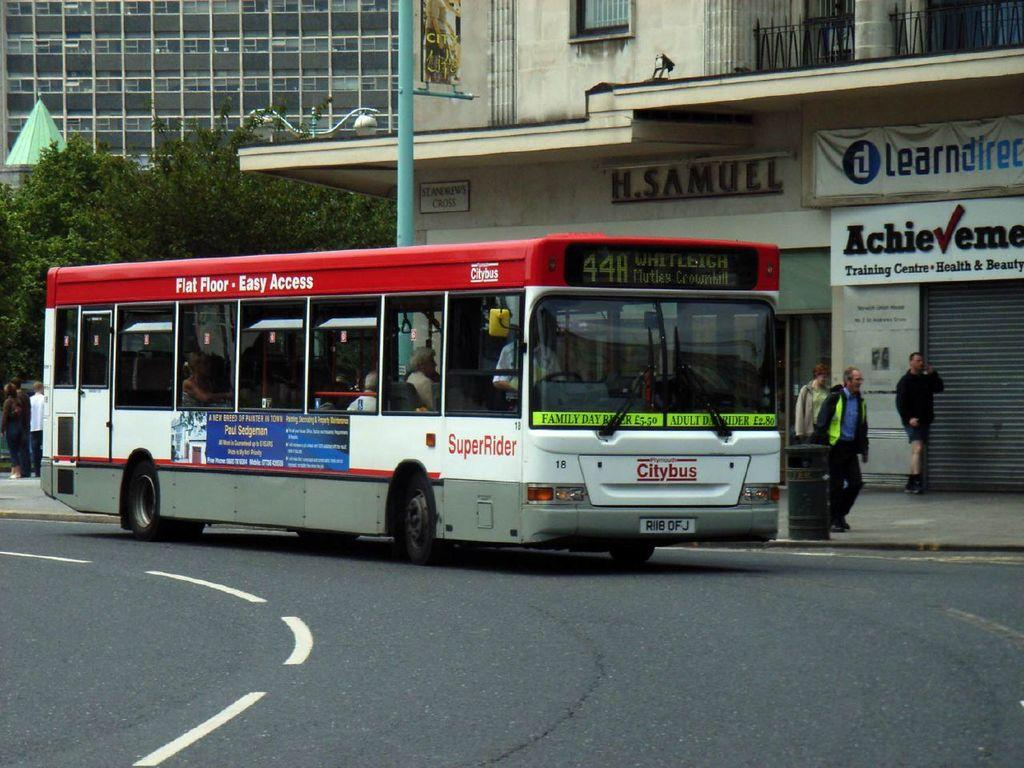What type of vehicle is on the road in the image? There is a bus on the road in the image. What can be seen in the background of the image? In the background of the image, there are people, a bin, buildings, boards, and trees. Are there any artificial light sources visible in the image? Yes, there are lights in the image. What structure can be seen in the image that is used for supporting objects? There is a pole in the image. What type of prose is being recited by the trees in the image? There is no prose being recited by the trees in the image, as trees do not have the ability to recite prose. 